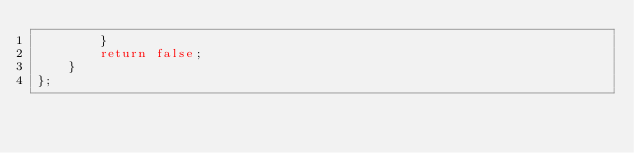<code> <loc_0><loc_0><loc_500><loc_500><_C++_>        }
        return false;
    }
};
</code> 